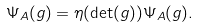<formula> <loc_0><loc_0><loc_500><loc_500>\Psi _ { A } ( g ) = \eta ( \det ( g ) ) \Psi _ { A } ( g ) .</formula> 